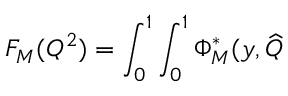<formula> <loc_0><loc_0><loc_500><loc_500>F _ { M } ( Q ^ { 2 } ) = \int _ { 0 } ^ { 1 } \int _ { 0 } ^ { 1 } \Phi _ { M } ^ { * } ( y , \widehat { Q }</formula> 